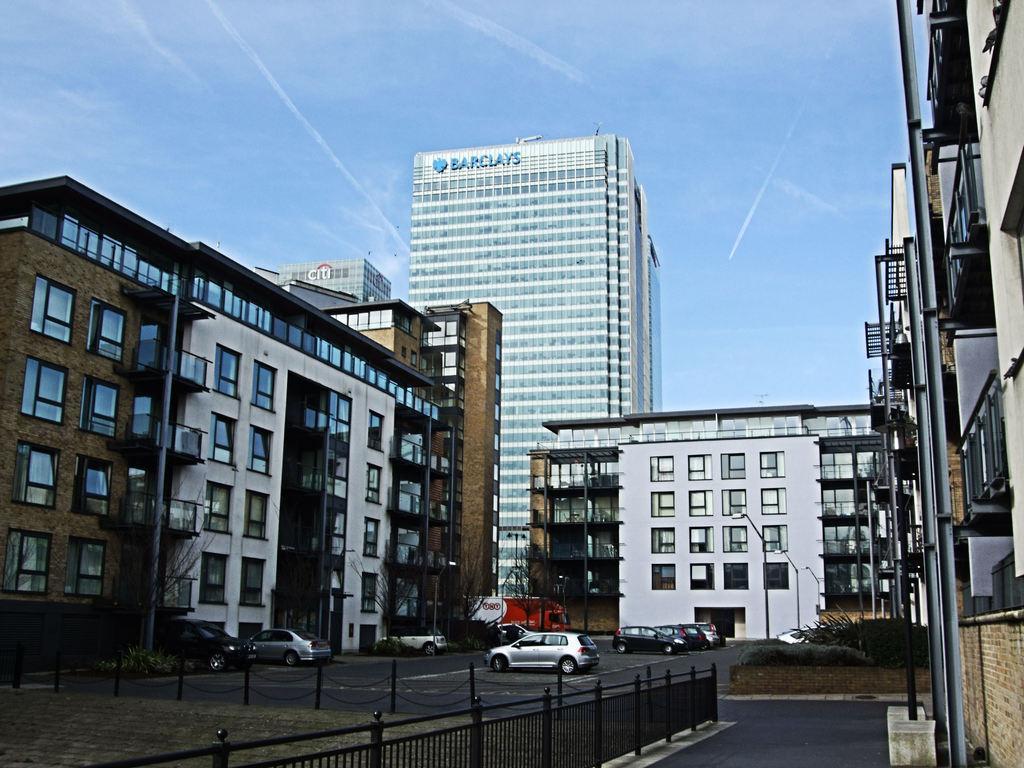How would you summarize this image in a sentence or two? In this picture we can see vehicles on the road, poles, fence, trees, buildings with windows, street light poles, plants and in the background we can see the sky. 